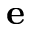Convert formula to latex. <formula><loc_0><loc_0><loc_500><loc_500>e</formula> 